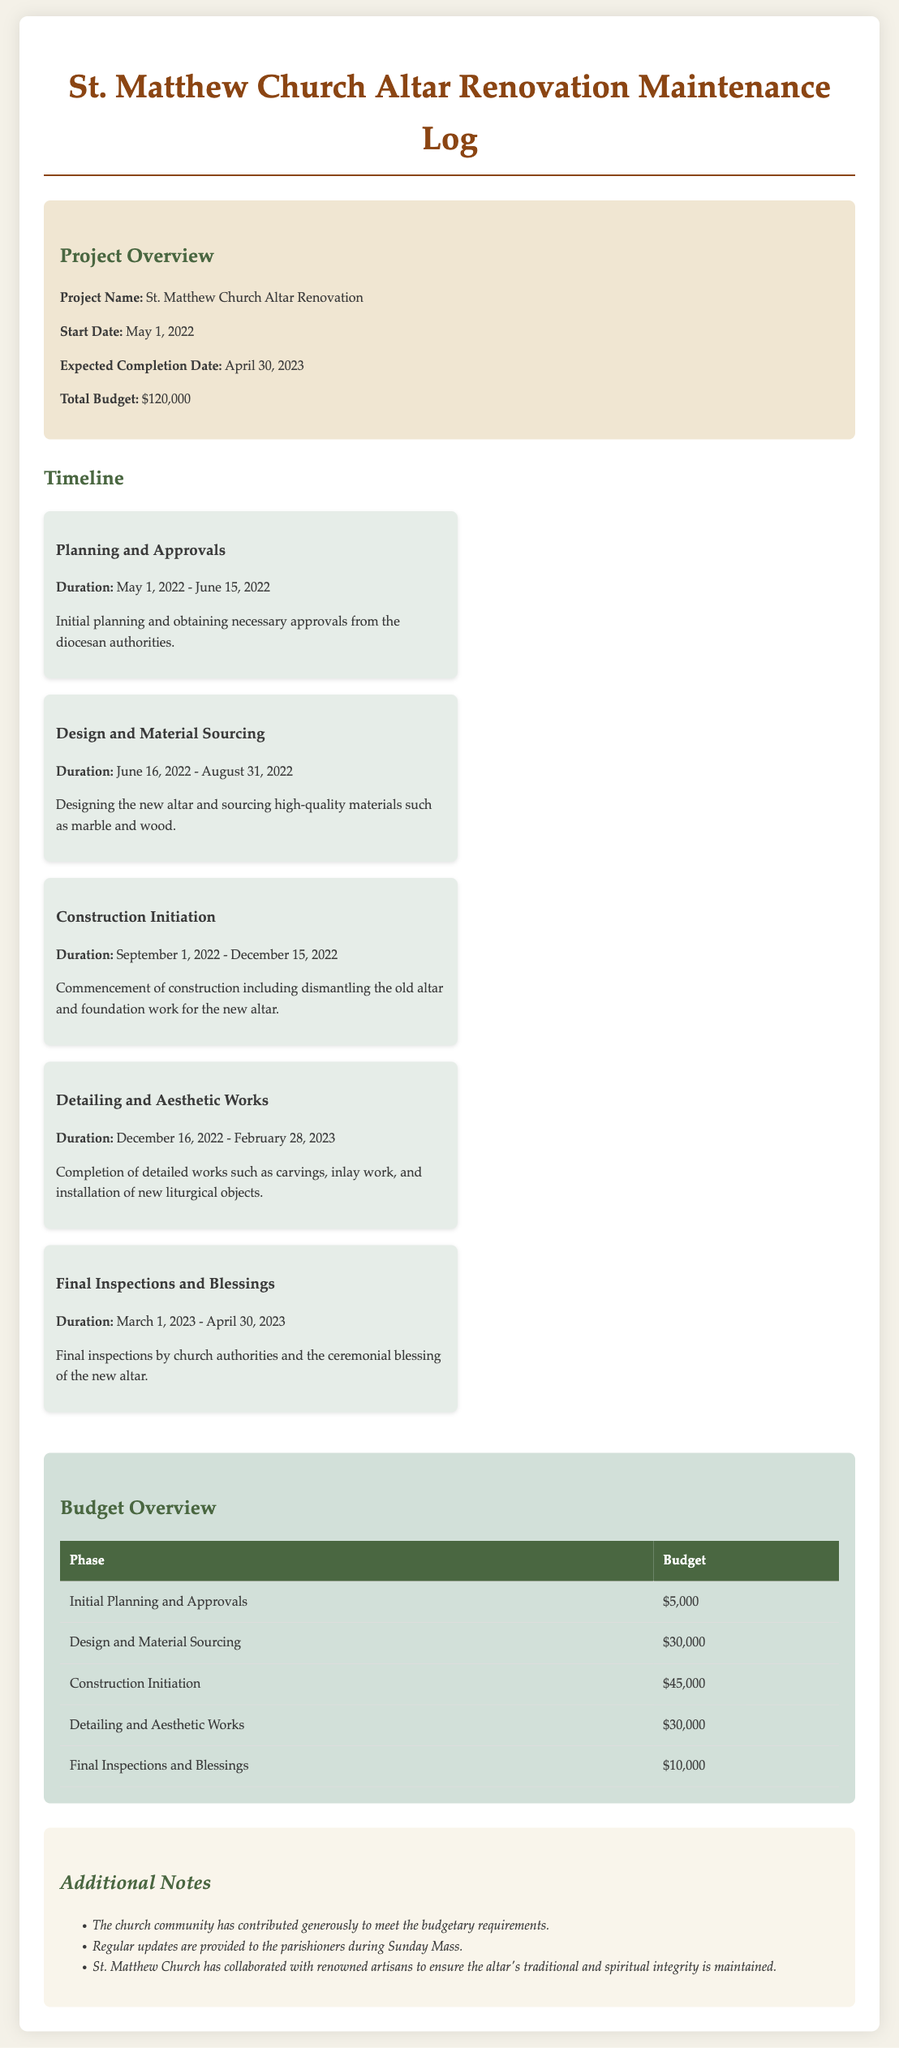what is the project name? The project name is mentioned in the overview section of the document as "St. Matthew Church Altar Renovation."
Answer: St. Matthew Church Altar Renovation what is the total budget for the renovation? The total budget is provided in the overview section of the document, which indicates a total of $120,000.
Answer: $120,000 what is the expected completion date? The expected completion date is explicitly stated in the overview section of the document as April 30, 2023.
Answer: April 30, 2023 how long did the detailing and aesthetic works last? The duration for detailing and aesthetic works is specified in the timeline section, lasting from December 16, 2022, to February 28, 2023. This is a total of 2.5 months.
Answer: 2.5 months which phase had the highest budget allocation? The budget overview table indicates that the phase "Construction Initiation" had the highest allocation of $45,000.
Answer: Construction Initiation how many phases are listed in the budget overview? The budget overview section includes five phases listed in the table.
Answer: 5 when did the construction initiation phase start? The timeline specifies that the construction initiation phase started on September 1, 2022.
Answer: September 1, 2022 what was the budget for final inspections and blessings? The budget overview table shows that the budget for final inspections and blessings is $10,000.
Answer: $10,000 how often are updates provided to the parishioners? The additional notes section states that regular updates are provided during Sunday Mass, implying that updates are provided weekly.
Answer: Sunday Mass 